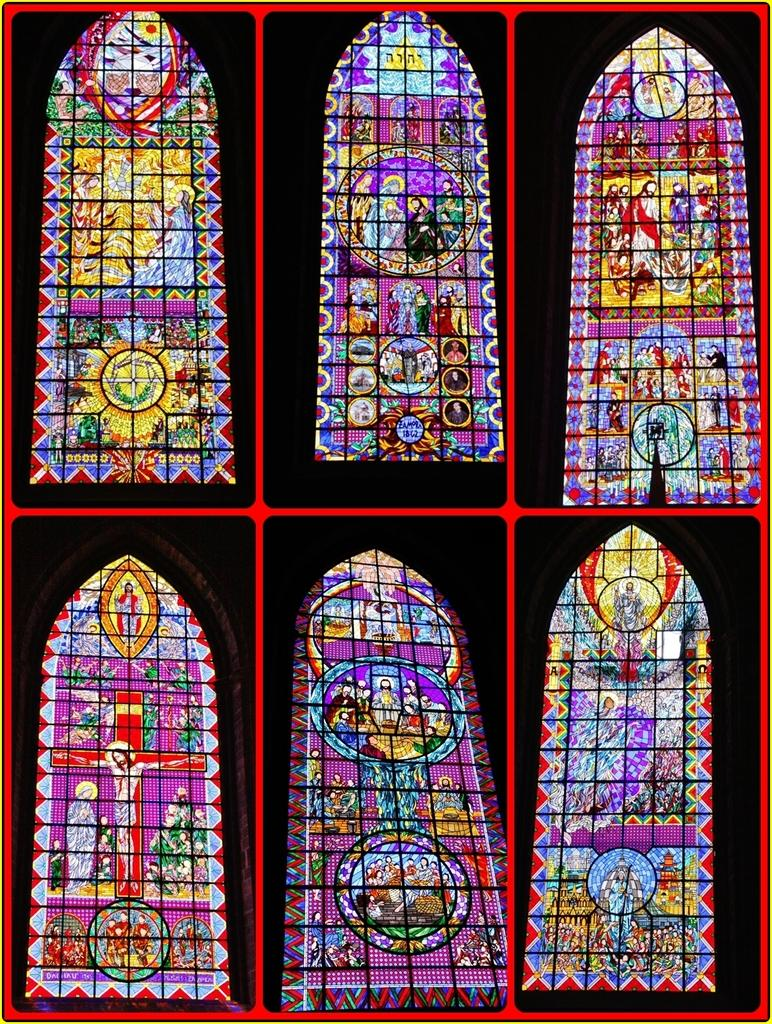What type of artwork is featured in the image? The image contains a collage of pictures. What subject matter is depicted in the pictures? The pictures depict stained glass. What type of business is being conducted in the image? There is no indication of a business in the image; it features a collage of pictures depicting stained glass. Can you see a lamp in the image? There is no lamp present in the image. 